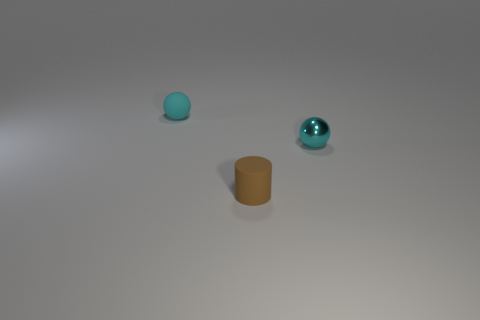Add 1 tiny cyan things. How many objects exist? 4 Subtract all balls. How many objects are left? 1 Subtract all big yellow balls. Subtract all cyan spheres. How many objects are left? 1 Add 3 small rubber objects. How many small rubber objects are left? 5 Add 1 cylinders. How many cylinders exist? 2 Subtract 0 blue cubes. How many objects are left? 3 